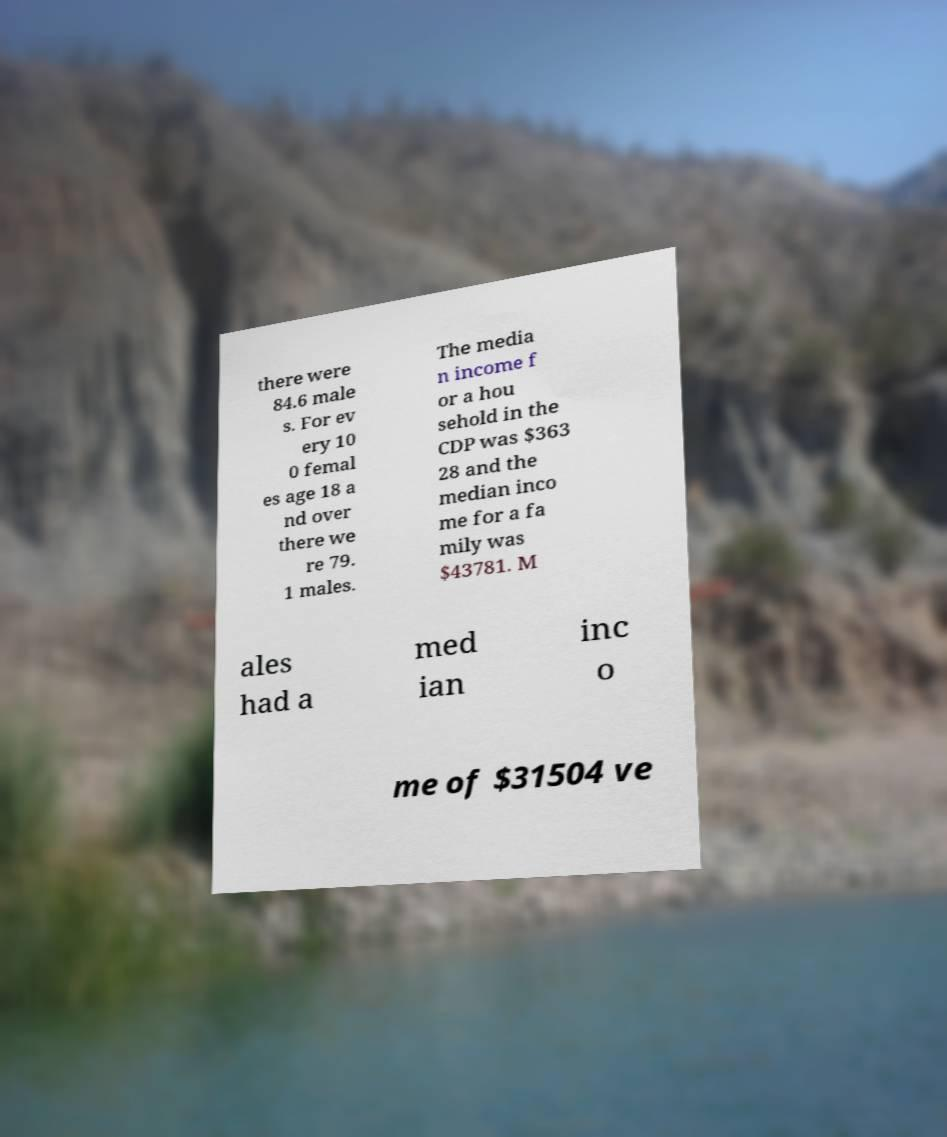Could you assist in decoding the text presented in this image and type it out clearly? there were 84.6 male s. For ev ery 10 0 femal es age 18 a nd over there we re 79. 1 males. The media n income f or a hou sehold in the CDP was $363 28 and the median inco me for a fa mily was $43781. M ales had a med ian inc o me of $31504 ve 